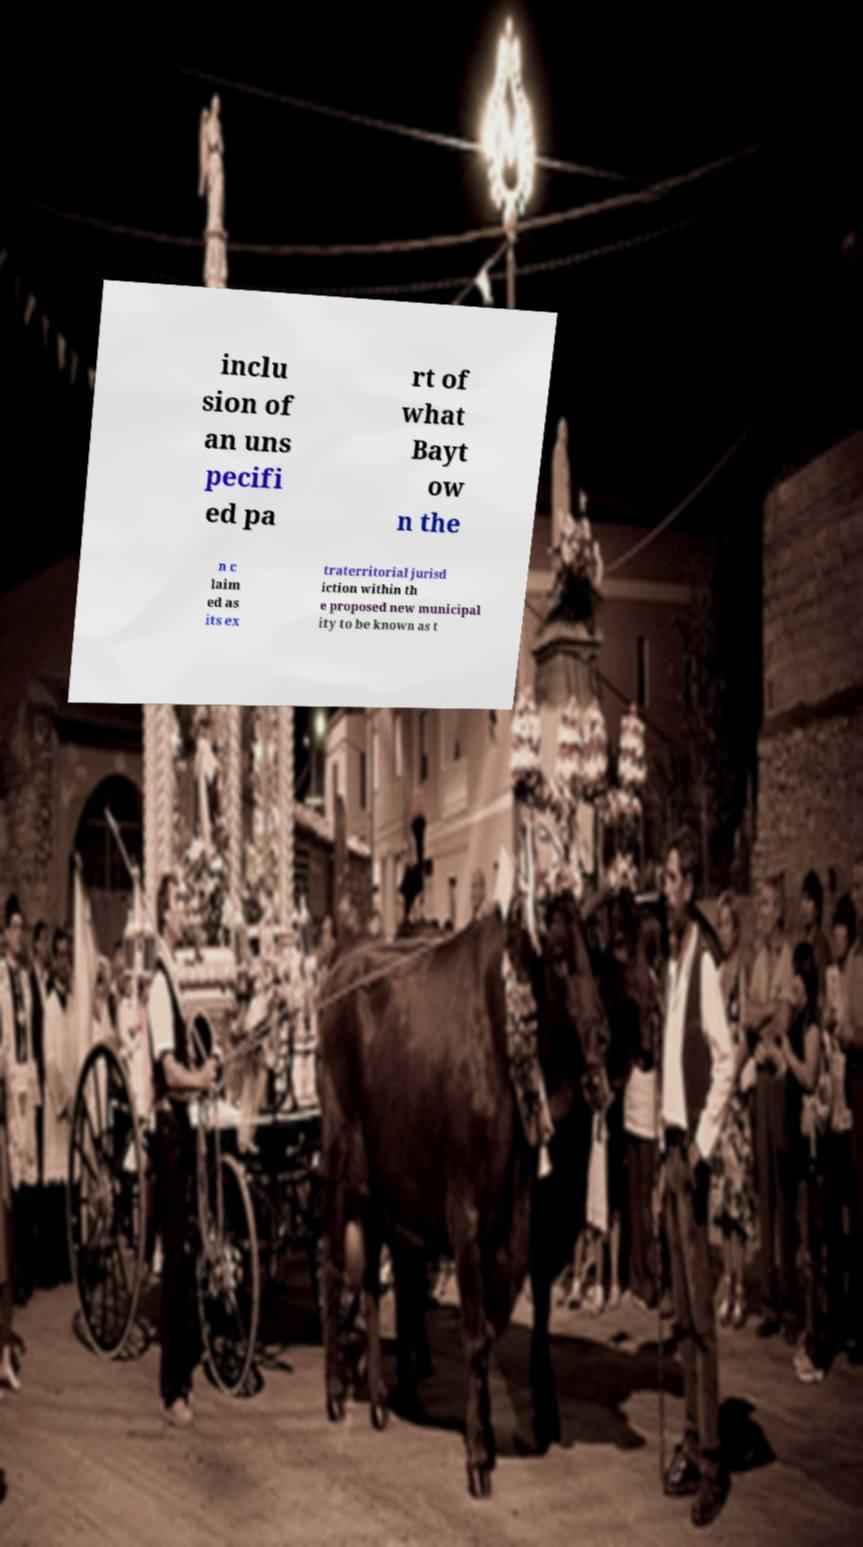Please read and relay the text visible in this image. What does it say? inclu sion of an uns pecifi ed pa rt of what Bayt ow n the n c laim ed as its ex traterritorial jurisd iction within th e proposed new municipal ity to be known as t 